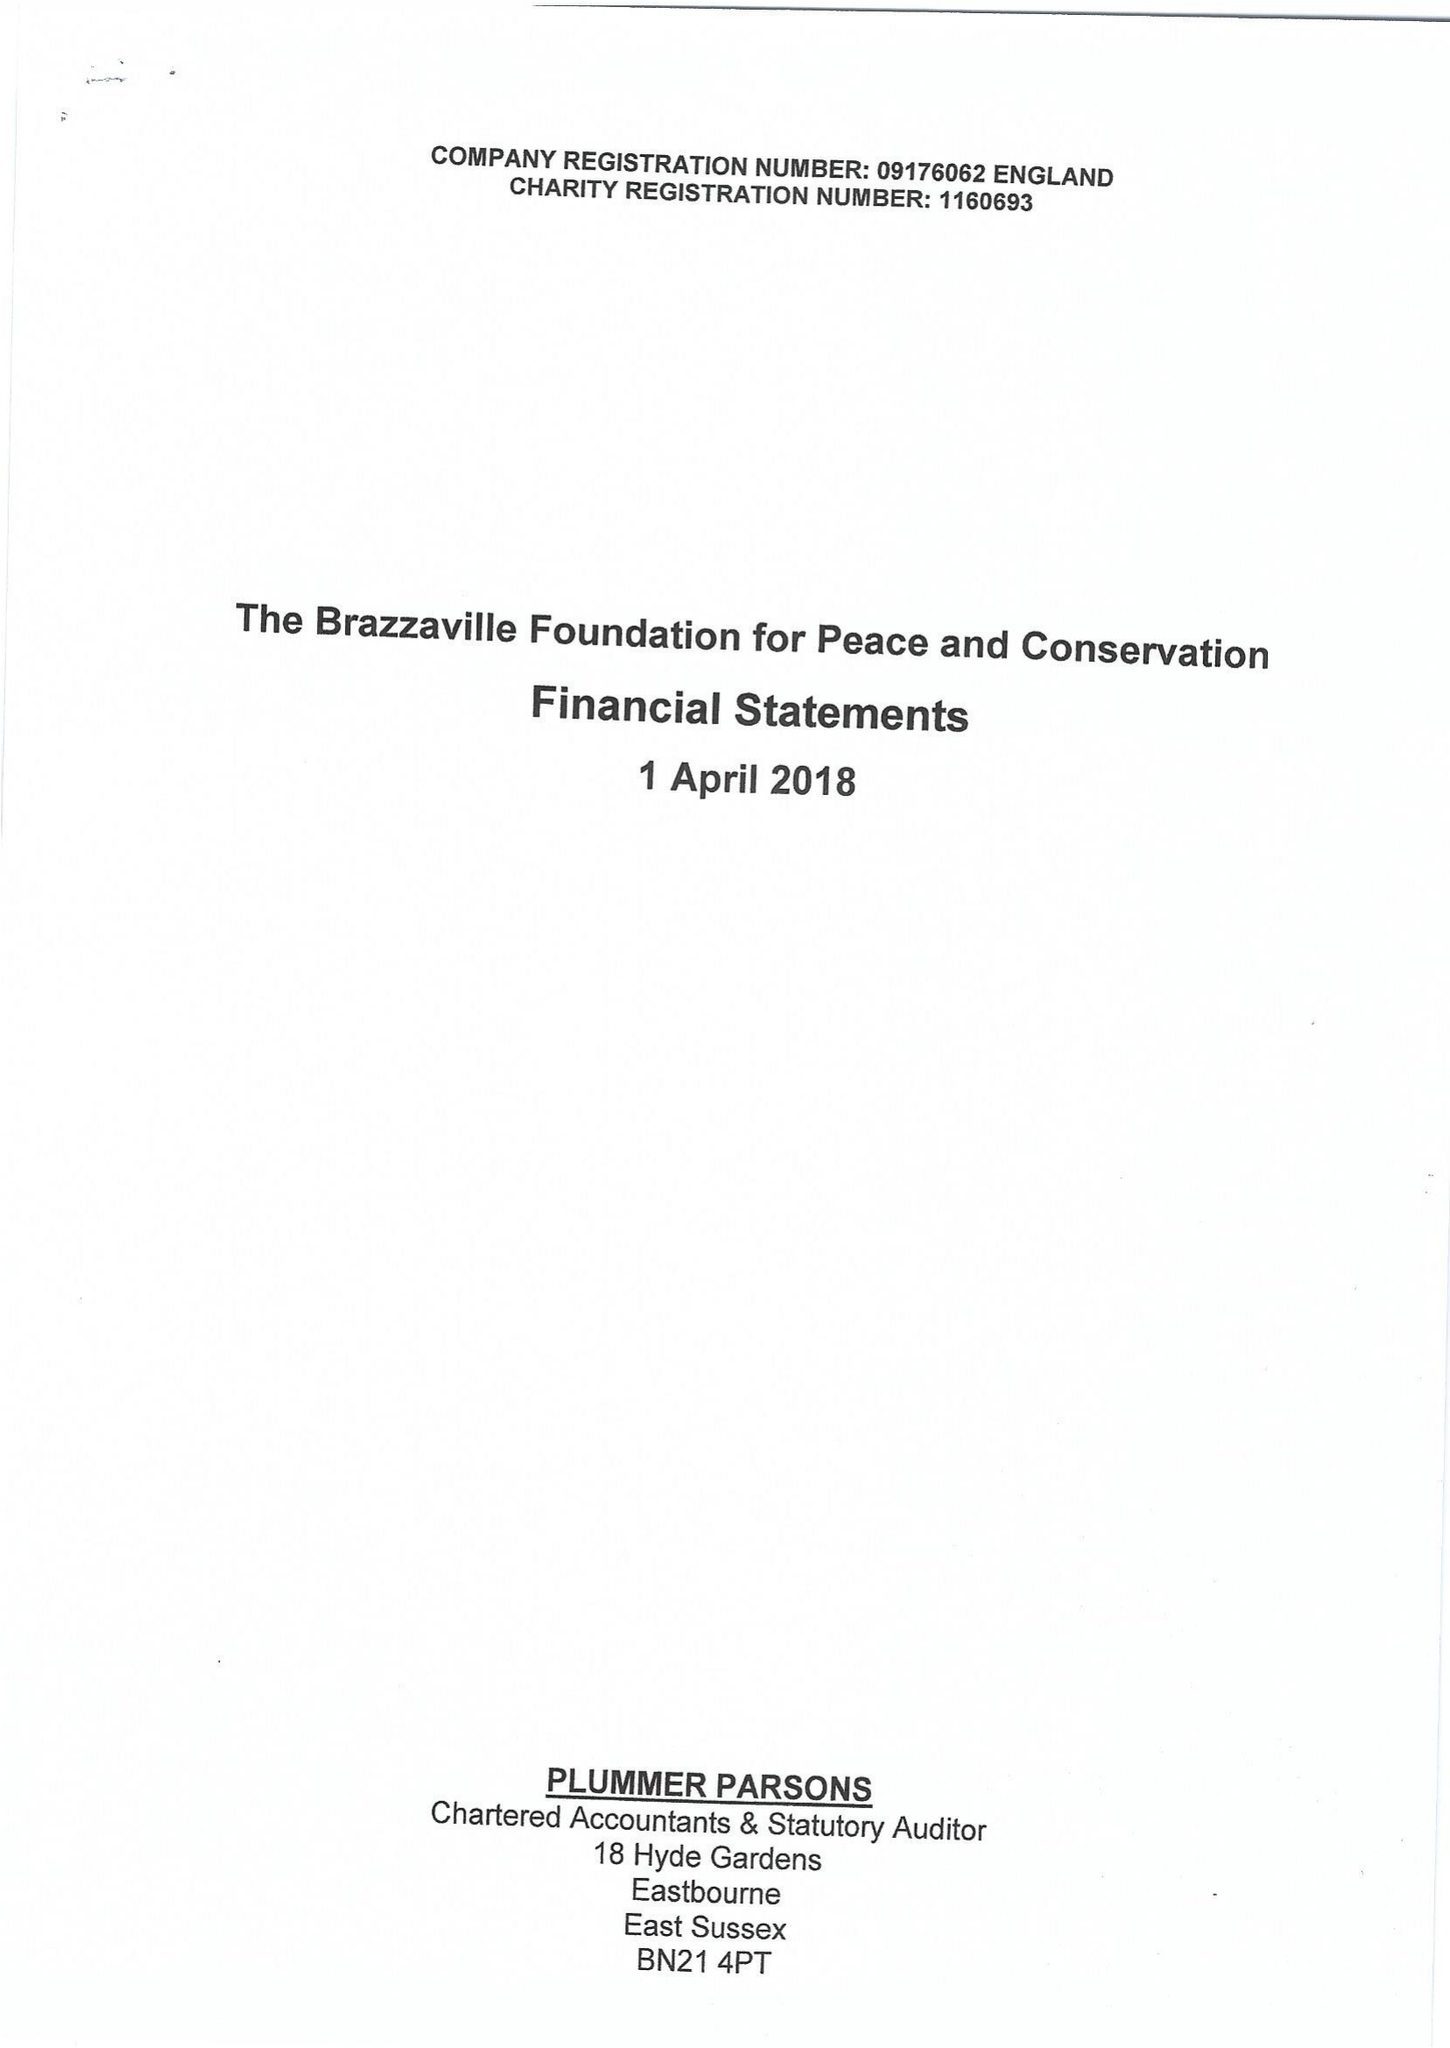What is the value for the spending_annually_in_british_pounds?
Answer the question using a single word or phrase. 414161.00 